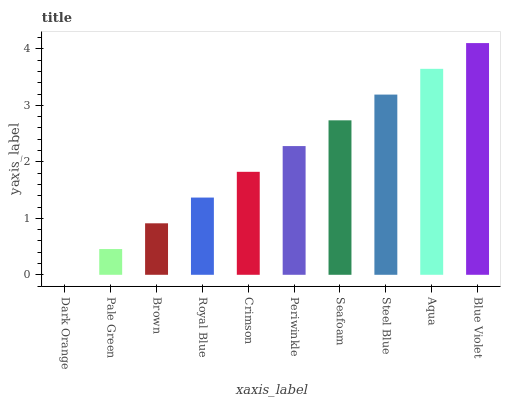Is Pale Green the minimum?
Answer yes or no. No. Is Pale Green the maximum?
Answer yes or no. No. Is Pale Green greater than Dark Orange?
Answer yes or no. Yes. Is Dark Orange less than Pale Green?
Answer yes or no. Yes. Is Dark Orange greater than Pale Green?
Answer yes or no. No. Is Pale Green less than Dark Orange?
Answer yes or no. No. Is Periwinkle the high median?
Answer yes or no. Yes. Is Crimson the low median?
Answer yes or no. Yes. Is Brown the high median?
Answer yes or no. No. Is Pale Green the low median?
Answer yes or no. No. 